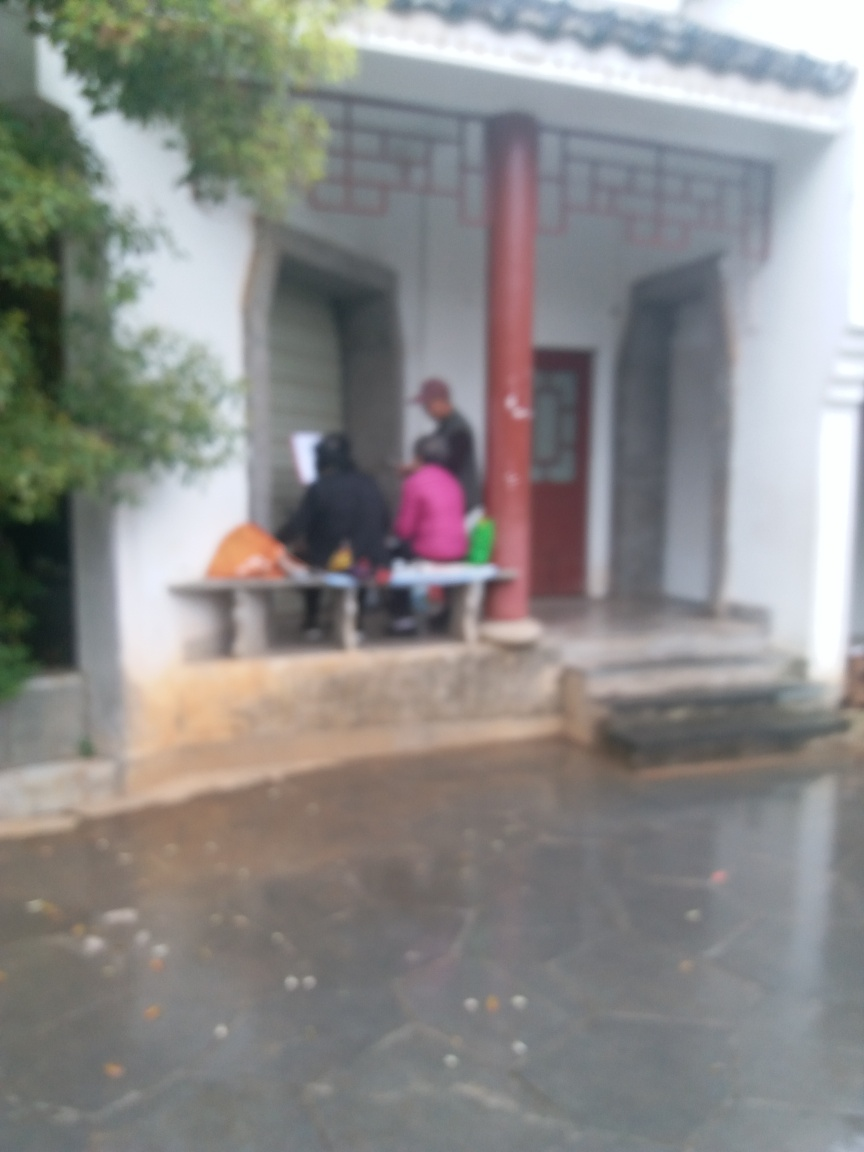What activities might the people be doing in this setting? Considering the informal gathering, they could be socializing, perhaps enjoying a casual conversation, or they might be participating in a local event or ritual pertinent to their culture. 